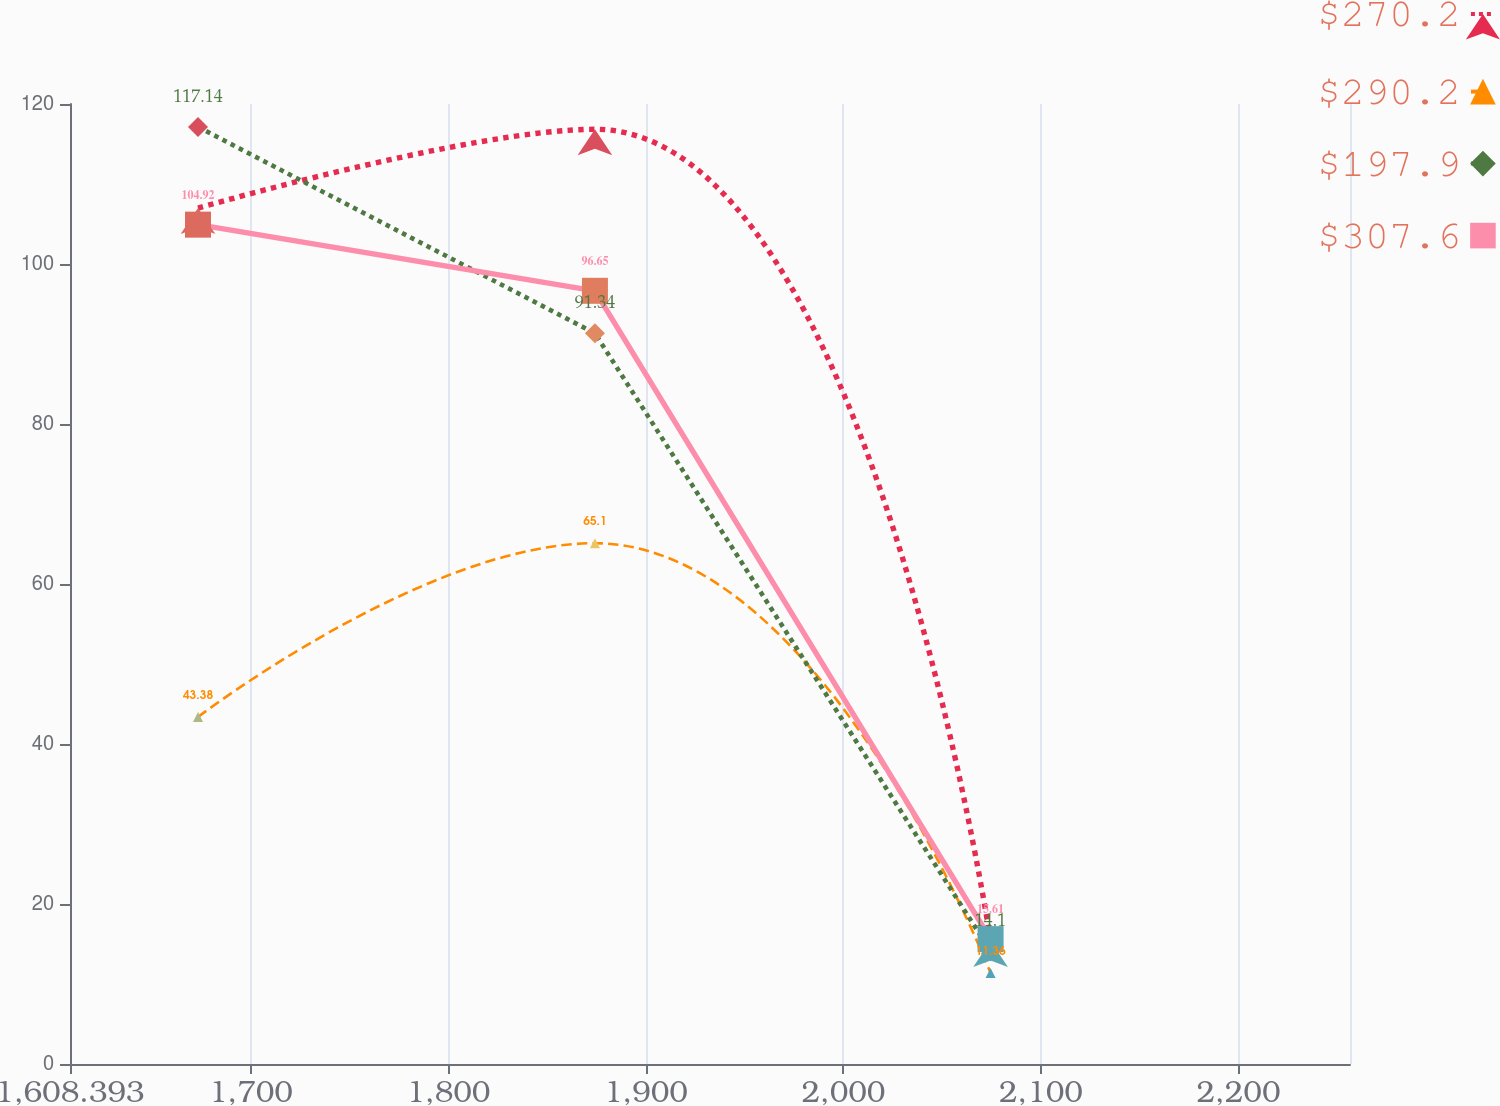Convert chart to OTSL. <chart><loc_0><loc_0><loc_500><loc_500><line_chart><ecel><fcel>$270.2<fcel>$290.2<fcel>$197.9<fcel>$307.6<nl><fcel>1673.2<fcel>106.99<fcel>43.38<fcel>117.14<fcel>104.92<nl><fcel>1874.17<fcel>116.84<fcel>65.1<fcel>91.34<fcel>96.65<nl><fcel>2074.49<fcel>15.38<fcel>11.36<fcel>14.1<fcel>15.61<nl><fcel>2321.27<fcel>73.85<fcel>35.77<fcel>65.17<fcel>55.54<nl></chart> 